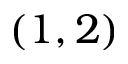Convert formula to latex. <formula><loc_0><loc_0><loc_500><loc_500>( 1 , 2 )</formula> 